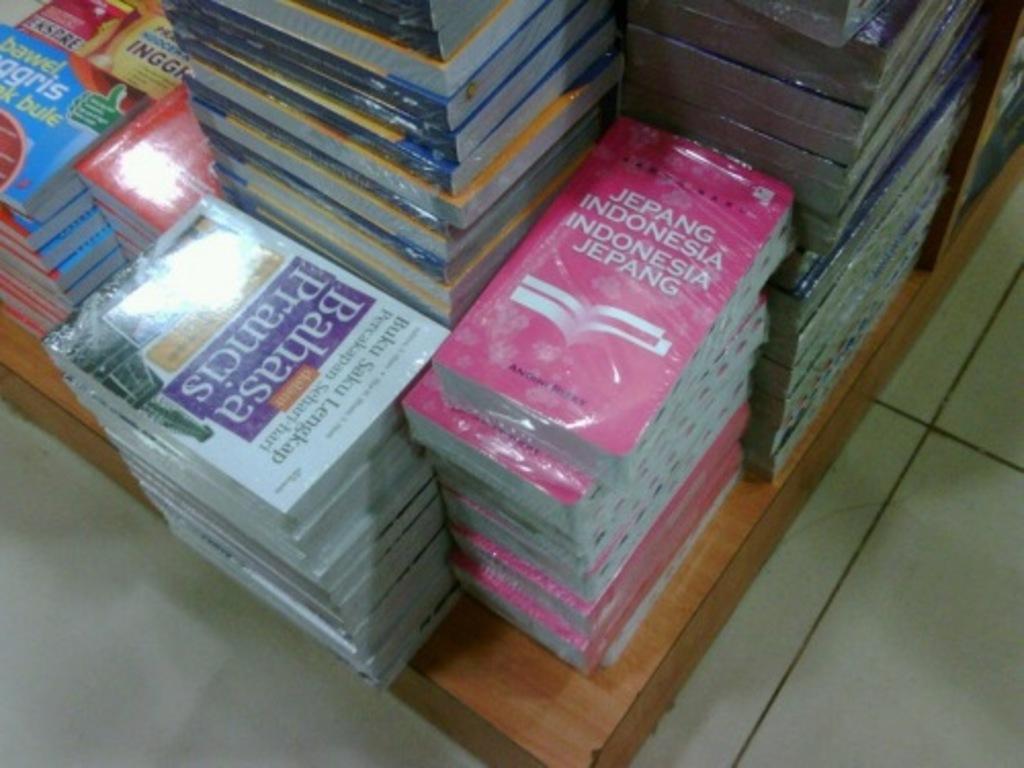What country is cited on the pink book?
Your response must be concise. Indonesia. What words are inside the purple box to the left?
Offer a terse response. Bahasa prancis. 